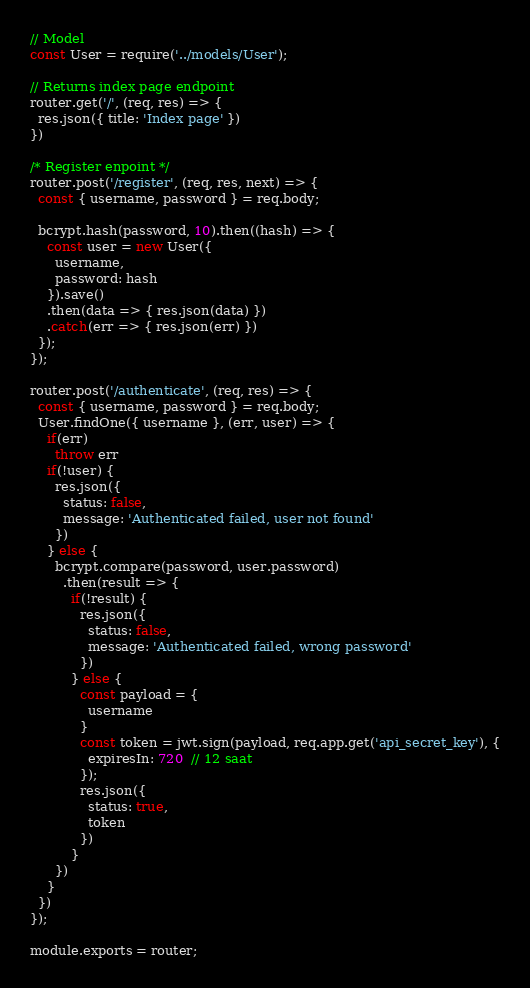<code> <loc_0><loc_0><loc_500><loc_500><_JavaScript_>// Model
const User = require('../models/User');

// Returns index page endpoint
router.get('/', (req, res) => {
  res.json({ title: 'Index page' })
})

/* Register enpoint */
router.post('/register', (req, res, next) => {
  const { username, password } = req.body;

  bcrypt.hash(password, 10).then((hash) => {
    const user = new User({
      username,
      password: hash
    }).save()
    .then(data => { res.json(data) })
    .catch(err => { res.json(err) })
  });  
});

router.post('/authenticate', (req, res) => {
  const { username, password } = req.body;
  User.findOne({ username }, (err, user) => {
    if(err) 
      throw err
    if(!user) {
      res.json({
        status: false,
        message: 'Authenticated failed, user not found'
      })
    } else {
      bcrypt.compare(password, user.password)
        .then(result => {
          if(!result) {
            res.json({
              status: false,
              message: 'Authenticated failed, wrong password'
            })
          } else {
            const payload = {
              username
            }
            const token = jwt.sign(payload, req.app.get('api_secret_key'), {
              expiresIn: 720  // 12 saat
            });
            res.json({
              status: true,
              token
            })
          }
      })
    }
  })
});

module.exports = router;
</code> 